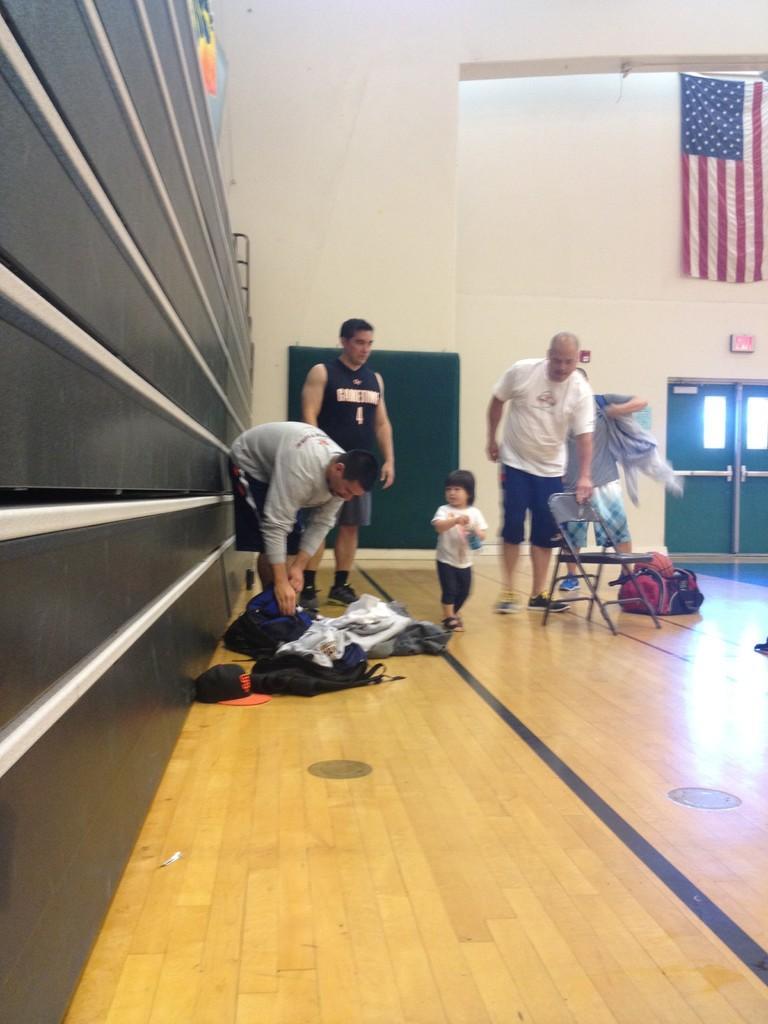Could you give a brief overview of what you see in this image? In this image I can see few people standing. I can see a chair,bags and few clothes on the floor. Back I can see a wall,flag and doors. 